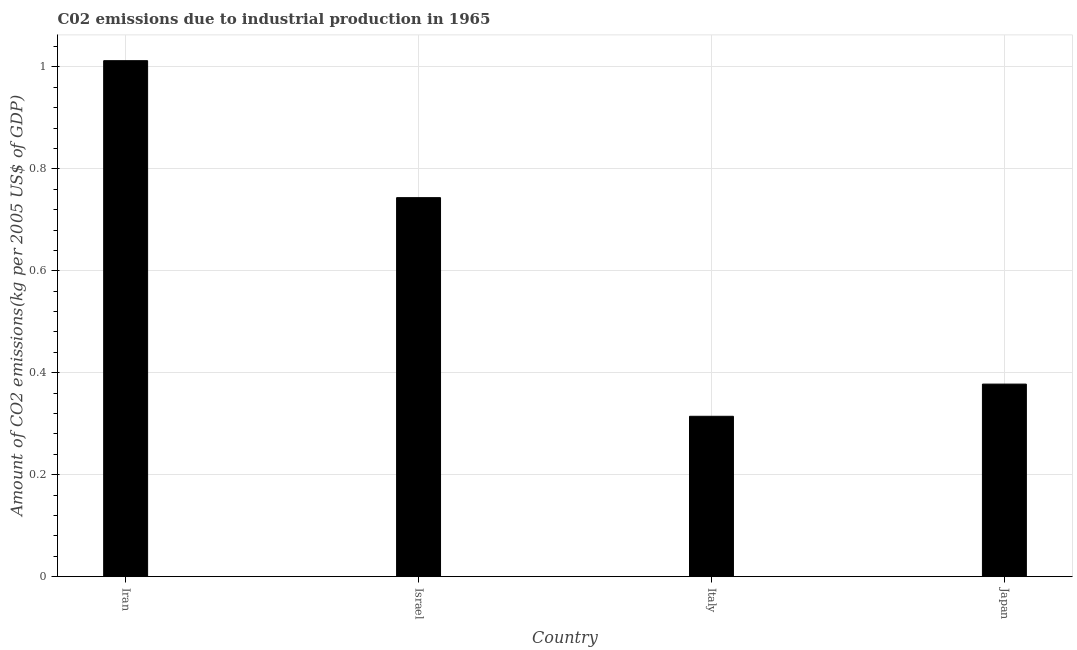Does the graph contain grids?
Make the answer very short. Yes. What is the title of the graph?
Your answer should be very brief. C02 emissions due to industrial production in 1965. What is the label or title of the X-axis?
Your answer should be compact. Country. What is the label or title of the Y-axis?
Provide a short and direct response. Amount of CO2 emissions(kg per 2005 US$ of GDP). What is the amount of co2 emissions in Japan?
Provide a succinct answer. 0.38. Across all countries, what is the maximum amount of co2 emissions?
Your answer should be compact. 1.01. Across all countries, what is the minimum amount of co2 emissions?
Make the answer very short. 0.31. In which country was the amount of co2 emissions maximum?
Your answer should be very brief. Iran. In which country was the amount of co2 emissions minimum?
Your response must be concise. Italy. What is the sum of the amount of co2 emissions?
Offer a very short reply. 2.45. What is the difference between the amount of co2 emissions in Iran and Israel?
Give a very brief answer. 0.27. What is the average amount of co2 emissions per country?
Give a very brief answer. 0.61. What is the median amount of co2 emissions?
Keep it short and to the point. 0.56. In how many countries, is the amount of co2 emissions greater than 0.76 kg per 2005 US$ of GDP?
Provide a short and direct response. 1. What is the ratio of the amount of co2 emissions in Iran to that in Israel?
Offer a very short reply. 1.36. What is the difference between the highest and the second highest amount of co2 emissions?
Provide a succinct answer. 0.27. Is the sum of the amount of co2 emissions in Iran and Israel greater than the maximum amount of co2 emissions across all countries?
Your response must be concise. Yes. What is the difference between the highest and the lowest amount of co2 emissions?
Ensure brevity in your answer.  0.7. How many bars are there?
Give a very brief answer. 4. How many countries are there in the graph?
Offer a very short reply. 4. What is the difference between two consecutive major ticks on the Y-axis?
Your answer should be compact. 0.2. What is the Amount of CO2 emissions(kg per 2005 US$ of GDP) in Iran?
Offer a terse response. 1.01. What is the Amount of CO2 emissions(kg per 2005 US$ of GDP) in Israel?
Your response must be concise. 0.74. What is the Amount of CO2 emissions(kg per 2005 US$ of GDP) in Italy?
Give a very brief answer. 0.31. What is the Amount of CO2 emissions(kg per 2005 US$ of GDP) in Japan?
Make the answer very short. 0.38. What is the difference between the Amount of CO2 emissions(kg per 2005 US$ of GDP) in Iran and Israel?
Offer a terse response. 0.27. What is the difference between the Amount of CO2 emissions(kg per 2005 US$ of GDP) in Iran and Italy?
Provide a short and direct response. 0.7. What is the difference between the Amount of CO2 emissions(kg per 2005 US$ of GDP) in Iran and Japan?
Make the answer very short. 0.63. What is the difference between the Amount of CO2 emissions(kg per 2005 US$ of GDP) in Israel and Italy?
Keep it short and to the point. 0.43. What is the difference between the Amount of CO2 emissions(kg per 2005 US$ of GDP) in Israel and Japan?
Provide a succinct answer. 0.37. What is the difference between the Amount of CO2 emissions(kg per 2005 US$ of GDP) in Italy and Japan?
Give a very brief answer. -0.06. What is the ratio of the Amount of CO2 emissions(kg per 2005 US$ of GDP) in Iran to that in Israel?
Provide a short and direct response. 1.36. What is the ratio of the Amount of CO2 emissions(kg per 2005 US$ of GDP) in Iran to that in Italy?
Make the answer very short. 3.22. What is the ratio of the Amount of CO2 emissions(kg per 2005 US$ of GDP) in Iran to that in Japan?
Keep it short and to the point. 2.68. What is the ratio of the Amount of CO2 emissions(kg per 2005 US$ of GDP) in Israel to that in Italy?
Provide a short and direct response. 2.36. What is the ratio of the Amount of CO2 emissions(kg per 2005 US$ of GDP) in Israel to that in Japan?
Offer a terse response. 1.97. What is the ratio of the Amount of CO2 emissions(kg per 2005 US$ of GDP) in Italy to that in Japan?
Your answer should be very brief. 0.83. 